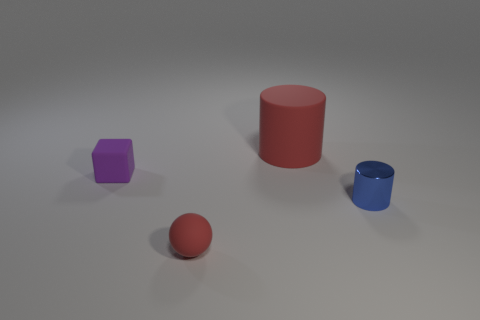Is there any other thing that is the same size as the matte cylinder?
Offer a terse response. No. What size is the matte cylinder that is the same color as the small sphere?
Offer a very short reply. Large. Are there any things?
Provide a short and direct response. Yes. There is a red matte thing behind the small cube; what is its size?
Keep it short and to the point. Large. What number of big cylinders have the same color as the matte sphere?
Your answer should be compact. 1. How many cylinders are either matte objects or blue things?
Offer a very short reply. 2. There is a thing that is both right of the purple cube and behind the blue metal object; what shape is it?
Offer a very short reply. Cylinder. Are there any metal objects of the same size as the red sphere?
Provide a succinct answer. Yes. How many objects are objects that are on the right side of the small purple thing or rubber cylinders?
Provide a succinct answer. 3. Do the purple cube and the tiny object on the right side of the rubber ball have the same material?
Offer a very short reply. No. 